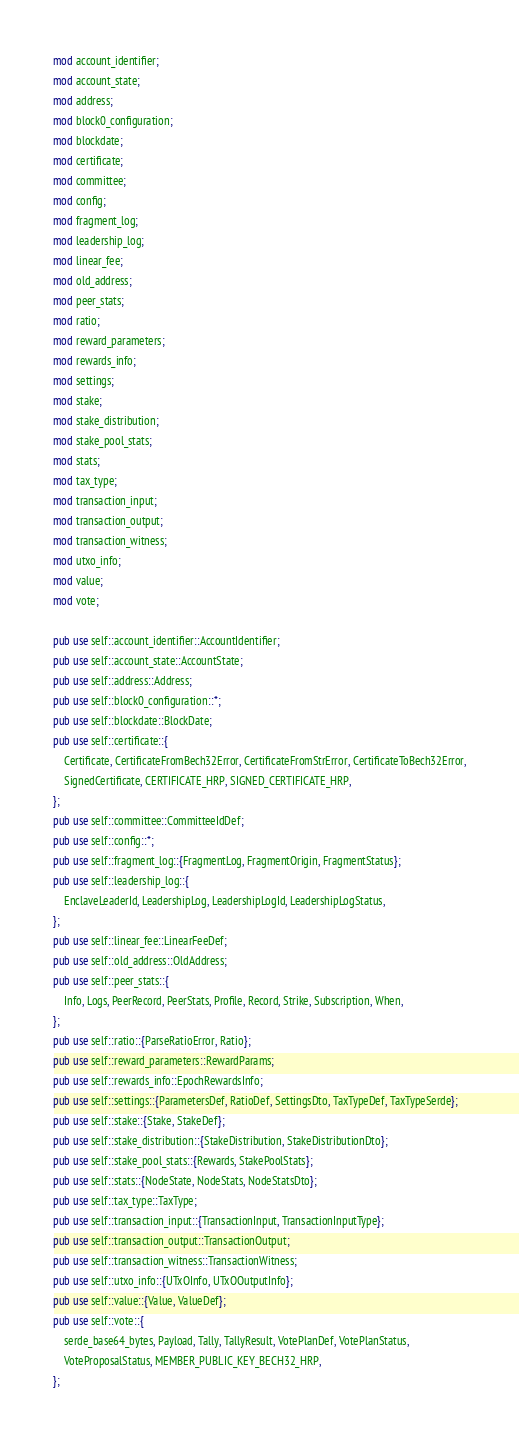Convert code to text. <code><loc_0><loc_0><loc_500><loc_500><_Rust_>mod account_identifier;
mod account_state;
mod address;
mod block0_configuration;
mod blockdate;
mod certificate;
mod committee;
mod config;
mod fragment_log;
mod leadership_log;
mod linear_fee;
mod old_address;
mod peer_stats;
mod ratio;
mod reward_parameters;
mod rewards_info;
mod settings;
mod stake;
mod stake_distribution;
mod stake_pool_stats;
mod stats;
mod tax_type;
mod transaction_input;
mod transaction_output;
mod transaction_witness;
mod utxo_info;
mod value;
mod vote;

pub use self::account_identifier::AccountIdentifier;
pub use self::account_state::AccountState;
pub use self::address::Address;
pub use self::block0_configuration::*;
pub use self::blockdate::BlockDate;
pub use self::certificate::{
    Certificate, CertificateFromBech32Error, CertificateFromStrError, CertificateToBech32Error,
    SignedCertificate, CERTIFICATE_HRP, SIGNED_CERTIFICATE_HRP,
};
pub use self::committee::CommitteeIdDef;
pub use self::config::*;
pub use self::fragment_log::{FragmentLog, FragmentOrigin, FragmentStatus};
pub use self::leadership_log::{
    EnclaveLeaderId, LeadershipLog, LeadershipLogId, LeadershipLogStatus,
};
pub use self::linear_fee::LinearFeeDef;
pub use self::old_address::OldAddress;
pub use self::peer_stats::{
    Info, Logs, PeerRecord, PeerStats, Profile, Record, Strike, Subscription, When,
};
pub use self::ratio::{ParseRatioError, Ratio};
pub use self::reward_parameters::RewardParams;
pub use self::rewards_info::EpochRewardsInfo;
pub use self::settings::{ParametersDef, RatioDef, SettingsDto, TaxTypeDef, TaxTypeSerde};
pub use self::stake::{Stake, StakeDef};
pub use self::stake_distribution::{StakeDistribution, StakeDistributionDto};
pub use self::stake_pool_stats::{Rewards, StakePoolStats};
pub use self::stats::{NodeState, NodeStats, NodeStatsDto};
pub use self::tax_type::TaxType;
pub use self::transaction_input::{TransactionInput, TransactionInputType};
pub use self::transaction_output::TransactionOutput;
pub use self::transaction_witness::TransactionWitness;
pub use self::utxo_info::{UTxOInfo, UTxOOutputInfo};
pub use self::value::{Value, ValueDef};
pub use self::vote::{
    serde_base64_bytes, Payload, Tally, TallyResult, VotePlanDef, VotePlanStatus,
    VoteProposalStatus, MEMBER_PUBLIC_KEY_BECH32_HRP,
};
</code> 